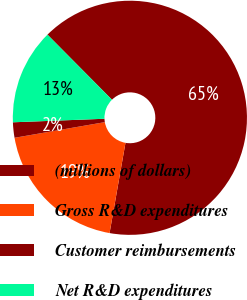<chart> <loc_0><loc_0><loc_500><loc_500><pie_chart><fcel>(millions of dollars)<fcel>Gross R&D expenditures<fcel>Customer reimbursements<fcel>Net R&D expenditures<nl><fcel>65.22%<fcel>19.49%<fcel>2.12%<fcel>13.18%<nl></chart> 